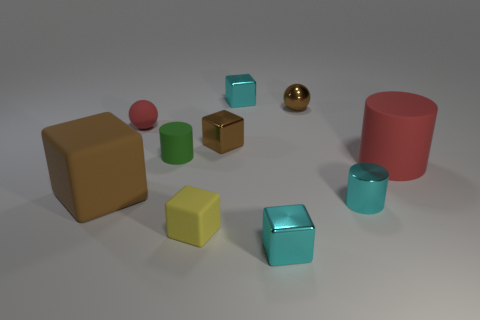What colors are represented in the objects seen here? The image displays objects in several colors: red, green, blue, yellow, brown, and a metallic gold. Notably, there are multiple shades of some colors, such as blue and green. 